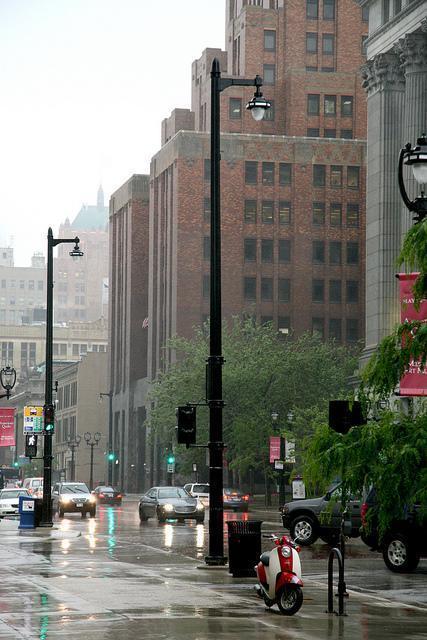How many cars are in the photo?
Give a very brief answer. 2. How many donuts have a pumpkin face?
Give a very brief answer. 0. 